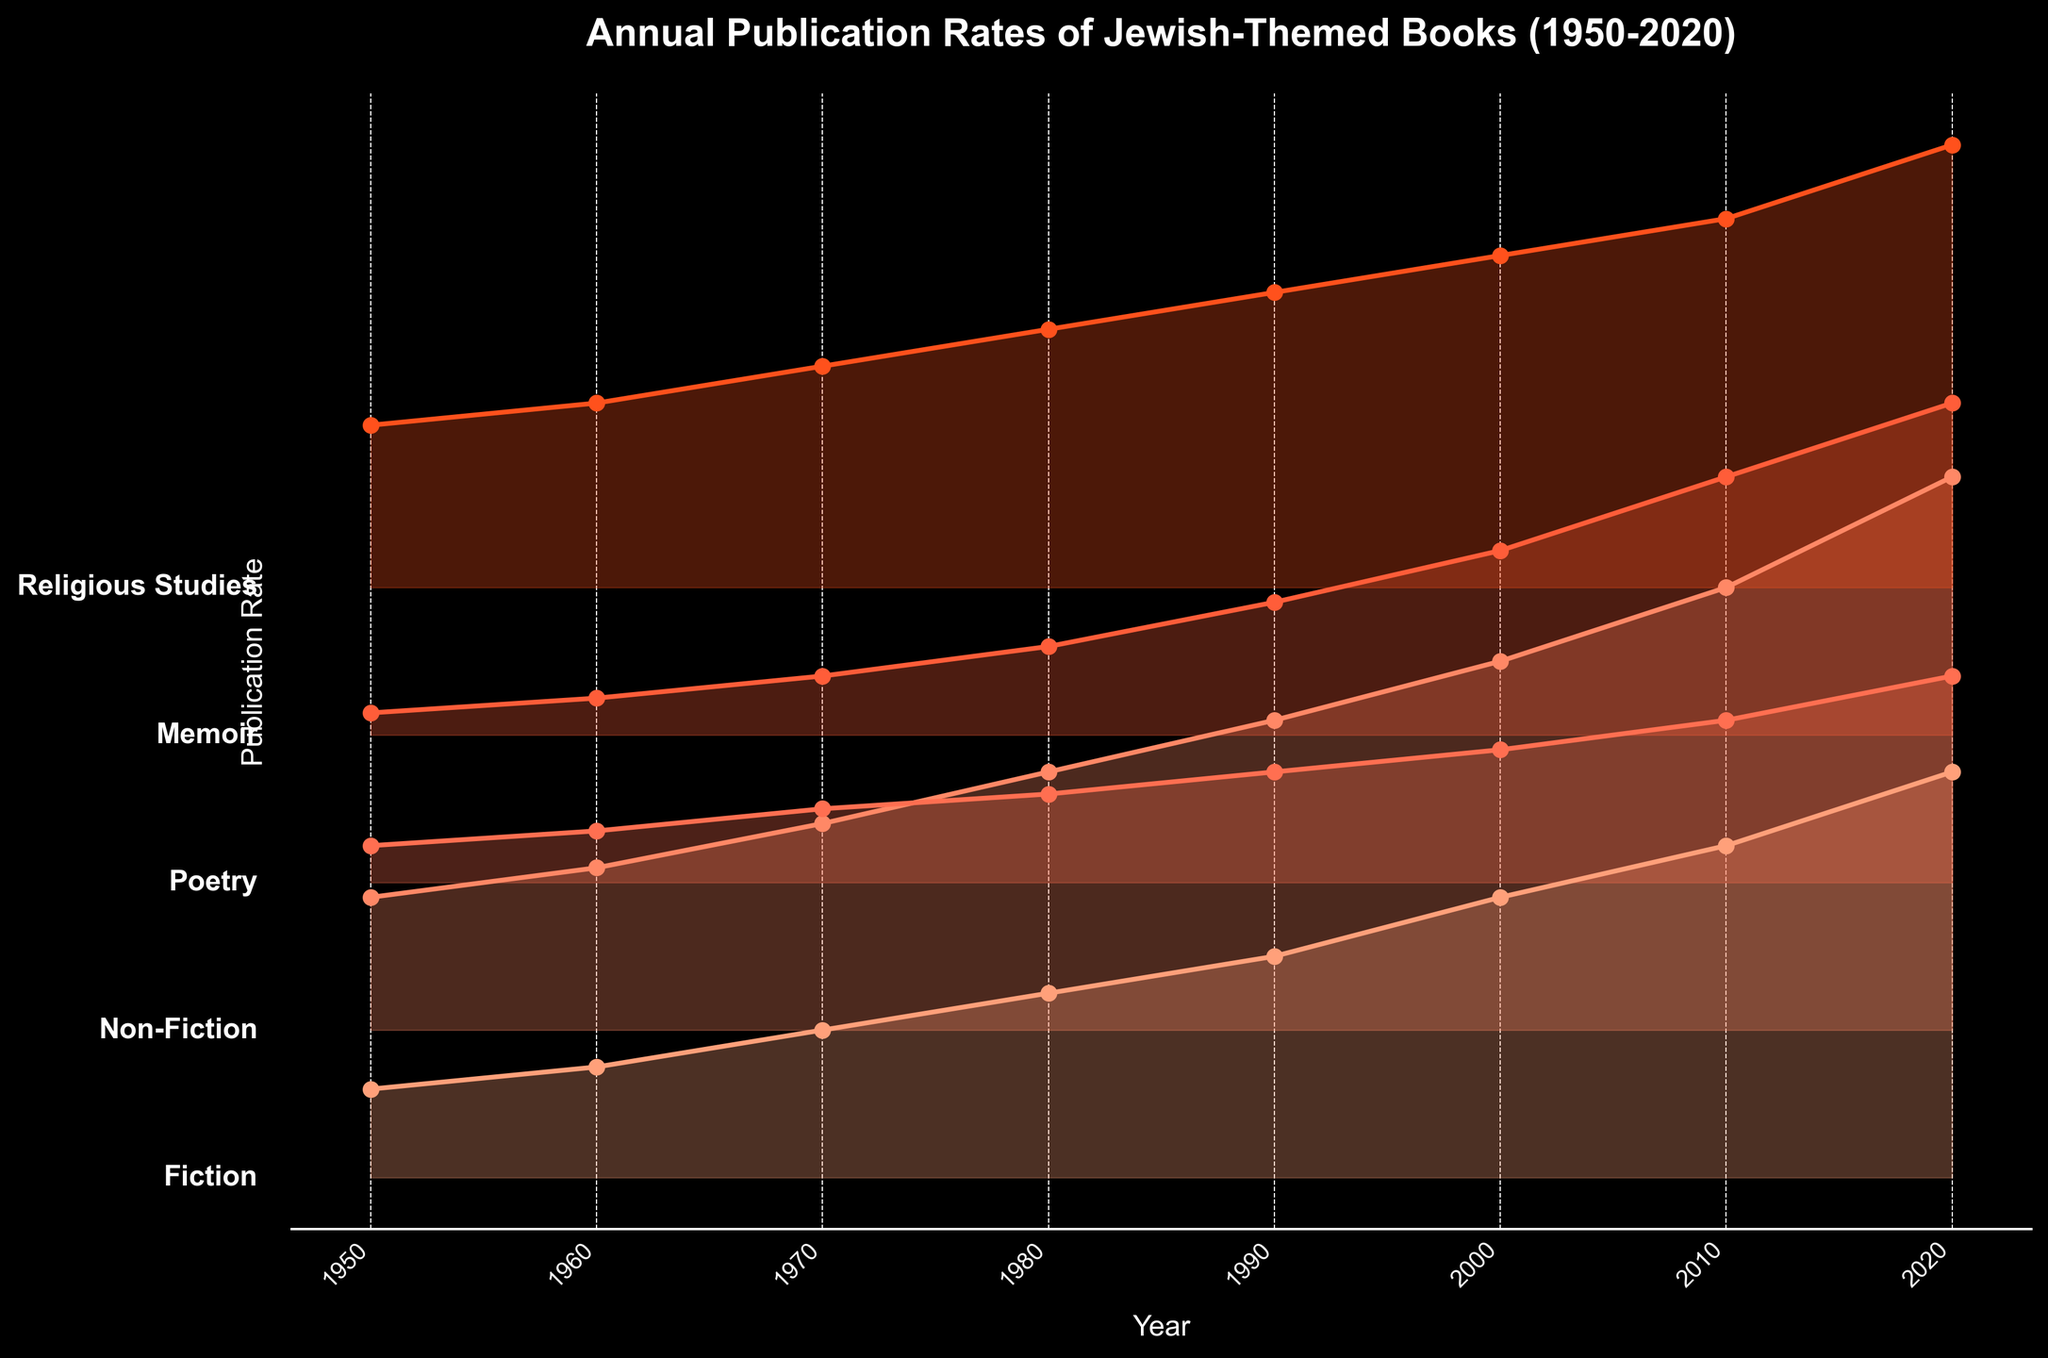How many genres are depicted in the plot? The plot shows the publication rates of different genres, each labeled along the vertical axis. By counting these labels, we identify that there are five genres.
Answer: 5 What is the title of the plot? The title of the plot is displayed at the top of the figure. By reading this, we see it is "Annual Publication Rates of Jewish-Themed Books (1950-2020)."
Answer: Annual Publication Rates of Jewish-Themed Books (1950-2020) Which genre had the highest publication rate in 2020? To find which genre had the highest publication rate in 2020, look at the endpoints of each line representing the genres for the year 2020. The highest value is for Religious Studies.
Answer: Religious Studies How has the publication rate for Fiction changed from 1950 to 2020? Look at the line representing Fiction from 1950 to 2020. In 1950, the rate is 12, and it increases to 55 in 2020. This indicates an upward trend.
Answer: Increased In which decade did Memoir publications grow the most? Look at the line representing Memoir and identify the decade with the steepest increase. From 2000 to 2010, Memoir publications grew from 25 to 35, an increase of 10, which is higher than other decades.
Answer: 2000-2010 Compare the publication rates of Poetry and Memoir in 1980. Which genre had a higher publication rate? In 1980, the line for Poetry shows a value of 12, while the line for Memoir shows a value of 12 as well. Comparing them directly shows they are equal.
Answer: Equal What is the total publication rate for all genres in 1990? Sum the values for all genres in 1990: Fiction (30) + Non-Fiction (42) + Poetry (15) + Memoir (18) + Religious Studies (40) = 145.
Answer: 145 What is the average publication rate of Non-Fiction across all years? Calculate by summing Non-Fiction publication rates for each year, then divide by 8 (number of years): (18 + 22 + 28 + 35 + 42 + 50 + 60 + 75) / 8 = 41.25.
Answer: 41.25 Which genre saw the smallest increase in publication rates from 1950 to 2020? By observing the differences for each genre over the period: Fiction (43), Non-Fiction (57), Poetry (23), Memoir (42), Religious Studies (38). Poetry had the smallest increase of 23.
Answer: Poetry 